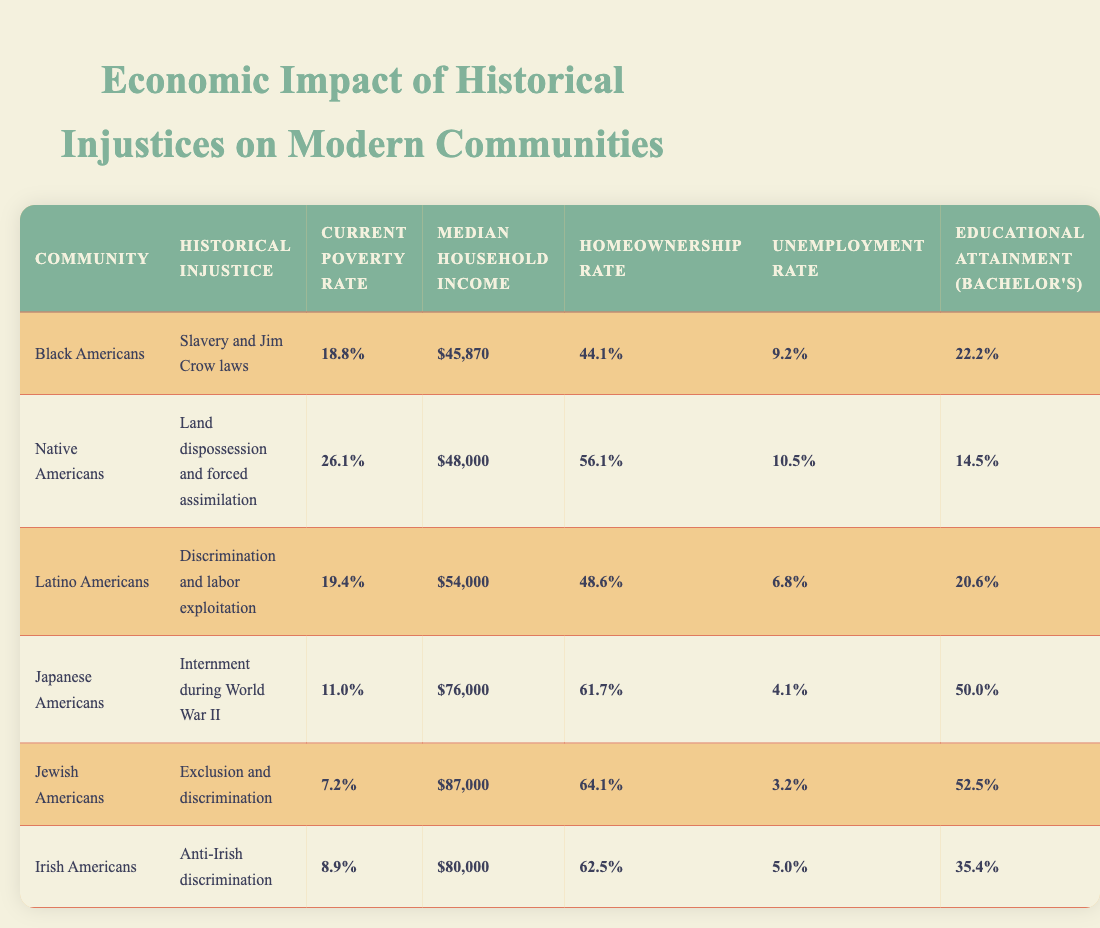What is the current poverty rate for Black Americans? The table shows that the current poverty rate for Black Americans is listed as 18.8%.
Answer: 18.8% Which community has the highest median household income? By comparing the values in the median household income column, Jewish Americans have the highest income at $87,000.
Answer: $87,000 What percentage of Japanese Americans have a bachelor's degree? The data indicates that 50.0% of Japanese Americans have attained a bachelor's degree.
Answer: 50.0% Is the homeownership rate for Latino Americans higher than 45%? The homeownership rate for Latino Americans is reported as 48.6%, which is indeed higher than 45%.
Answer: True Which community has both the highest homeownership rate and the lowest unemployment rate? Examining the homeownership and unemployment rate columns, Jewish Americans have the highest homeownership rate at 64.1% and the lowest unemployment rate at 3.2%.
Answer: Jewish Americans What is the average current poverty rate for the communities listed? To find the average, add the poverty rates (18.8% + 26.1% + 19.4% + 11.0% + 7.2% + 8.9%) = 91.4%, then divide by 6 (the number of communities) to get 15.23%.
Answer: 15.2% Which community has the highest unemployment rate and what is that rate? The table shows that Native Americans have the highest unemployment rate at 10.5%.
Answer: Native Americans at 10.5% If we consider the educational attainment, which community has the lowest percentage of bachelor's degree attainment? The educational attainment for each group shows that Native Americans have the lowest percentage at 14.5%.
Answer: 14.5% What is the difference in median household income between Latino Americans and Black Americans? The median household income for Latino Americans is $54,000 and for Black Americans is $45,870. Subtracting these values gives $54,000 - $45,870 = $8,130.
Answer: $8,130 Are the current poverty rates for Jewish Americans and Irish Americans both under 9%? The current poverty rate for Jewish Americans is 7.2% and for Irish Americans is 8.9%, both of which are under 9%.
Answer: True 